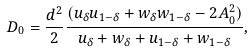<formula> <loc_0><loc_0><loc_500><loc_500>D _ { 0 } = \frac { d ^ { 2 } } { 2 } \frac { { ( u _ { \delta } u _ { 1 - \delta } + w _ { \delta } w _ { 1 - \delta } - 2 A _ { 0 } ^ { 2 } ) } } { { u _ { \delta } + w _ { \delta } + u _ { 1 - \delta } + w _ { 1 - \delta } } } ,</formula> 